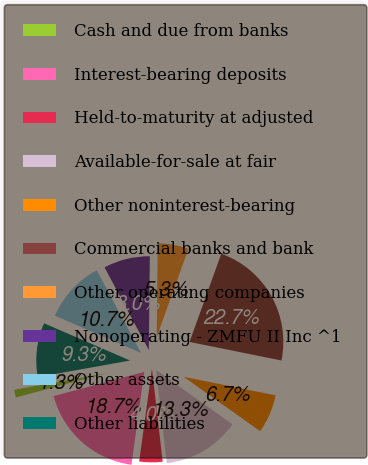Convert chart. <chart><loc_0><loc_0><loc_500><loc_500><pie_chart><fcel>Cash and due from banks<fcel>Interest-bearing deposits<fcel>Held-to-maturity at adjusted<fcel>Available-for-sale at fair<fcel>Other noninterest-bearing<fcel>Commercial banks and bank<fcel>Other operating companies<fcel>Nonoperating - ZMFU II Inc ^1<fcel>Other assets<fcel>Other liabilities<nl><fcel>1.33%<fcel>18.67%<fcel>4.0%<fcel>13.33%<fcel>6.67%<fcel>22.67%<fcel>5.33%<fcel>8.0%<fcel>10.67%<fcel>9.33%<nl></chart> 